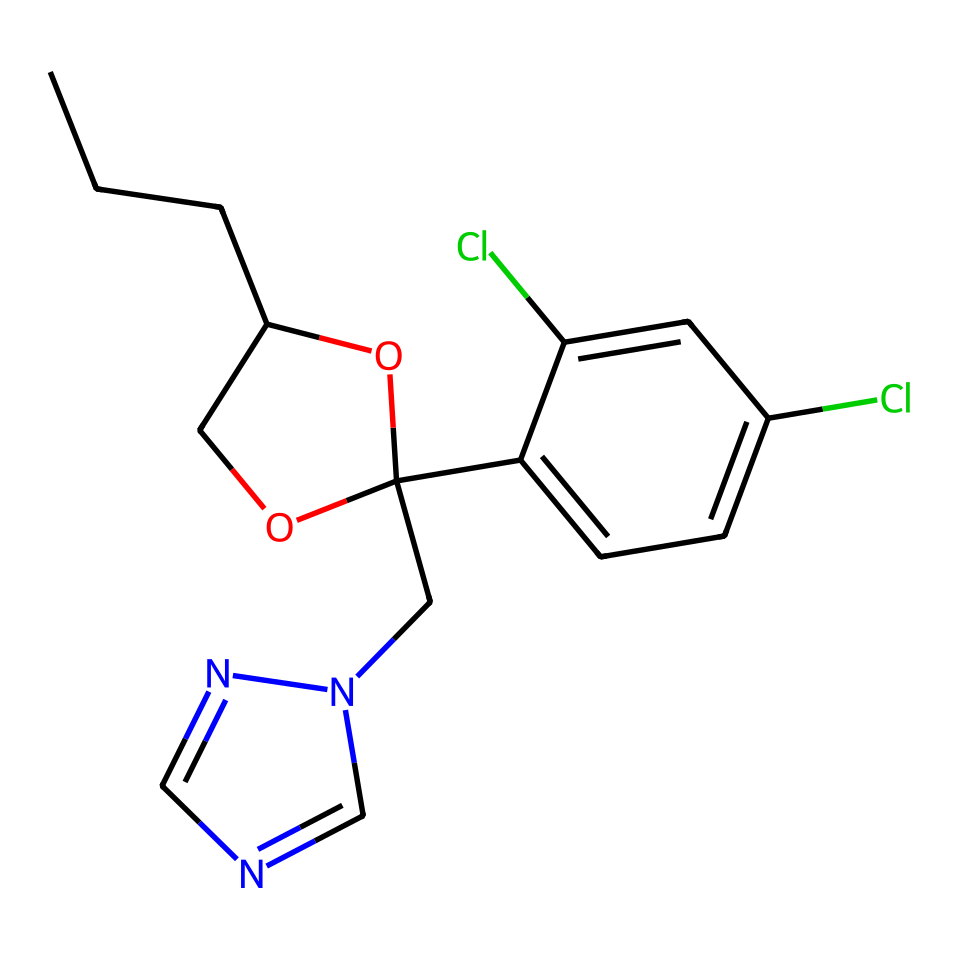What is the total number of carbon atoms in this structure? To find the number of carbon atoms, you count the 'C' symbols present in the SMILES notation. Each 'C' represents one carbon atom. By identifying and counting all the carbon symbols, you determine that there are 14 carbon atoms in total.
Answer: 14 How many chlorine atoms are there in the structure? In the provided SMILES notation, the chlorine atoms are represented by the 'Cl' symbols. By counting these occurrences in the structure, we find there are 2 chlorine atoms present.
Answer: 2 What functional groups are present in propiconazole? By examining the structure, we can identify functional groups such as the ether (C-O-C), hydroxyl (-OH), and amine (C-N). These are characteristic of many fungicides, including propiconazole.
Answer: ether, hydroxyl, amine What type of chemical is propiconazole categorized as? Propiconazole is categorized as a fungicide, specifically a triazole fungicide, as indicated by the presence of the triazole ring in the structure (the nitrogen and carbon arrangement that forms a five-membered ring).
Answer: triazole What is the molecular weight of propiconazole? To determine the molecular weight, we would sum the atomic weights of all the atoms present in the structure: carbons, hydrogens, nitrogens, oxygens, and chlorines. This would require detailed knowledge of the average atomic weights, leading to a molecular weight of approximately 340 g/mol.
Answer: 340 g/mol How does the structure of propiconazole affect its application in wood preservation? The stable, complex structure of propiconazole, including its multiple rings and functional groups, contributes to its effectiveness as a fungicide in preventing fungal growth while being less volatile, making it suitable for use in wood preservation.
Answer: stable, effective 